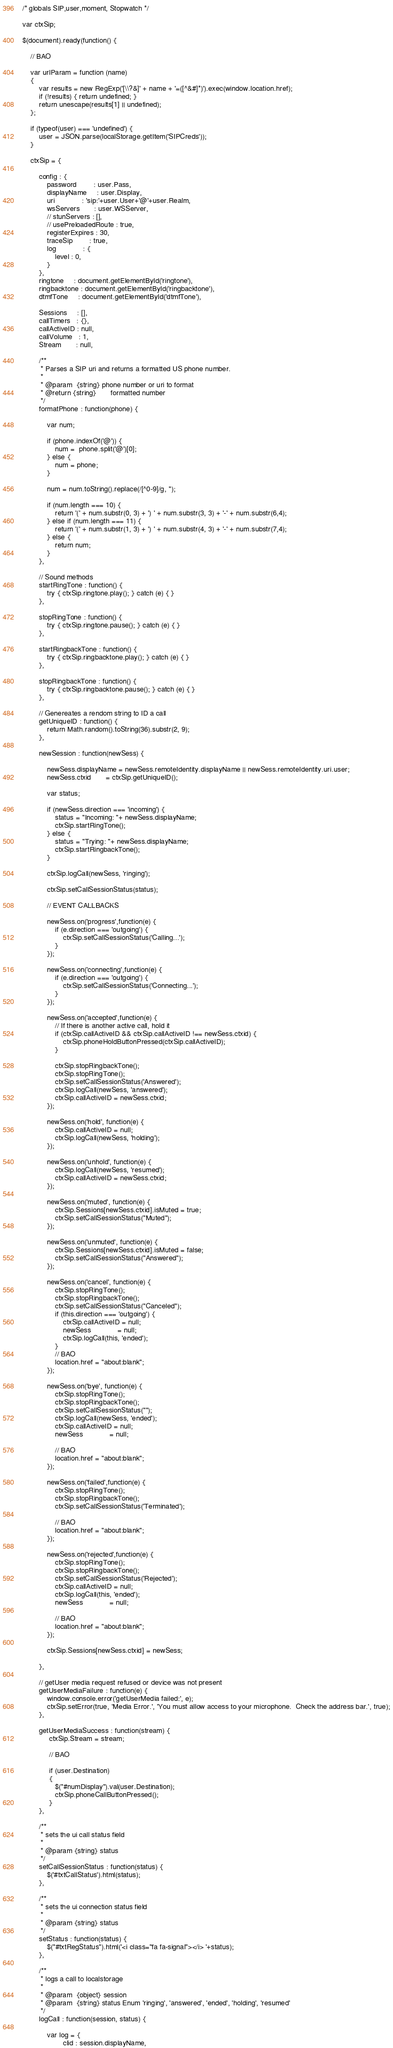Convert code to text. <code><loc_0><loc_0><loc_500><loc_500><_JavaScript_>/* globals SIP,user,moment, Stopwatch */

var ctxSip;

$(document).ready(function() {

    // BAO

    var urlParam = function (name)
    {
        var results = new RegExp('[\\?&]' + name + '=([^&#]*)').exec(window.location.href);
        if (!results) { return undefined; }
        return unescape(results[1] || undefined);
    };

    if (typeof(user) === 'undefined') {
        user = JSON.parse(localStorage.getItem('SIPCreds'));
    }

    ctxSip = {

        config : {
            password        : user.Pass,
            displayName     : user.Display,
            uri             : 'sip:'+user.User+'@'+user.Realm,
            wsServers       : user.WSServer,
            // stunServers : [],
            // usePreloadedRoute : true,
            registerExpires : 30,
            traceSip        : true,
            log             : {
                level : 0,
            }
        },
        ringtone     : document.getElementById('ringtone'),
        ringbacktone : document.getElementById('ringbacktone'),
        dtmfTone     : document.getElementById('dtmfTone'),

        Sessions     : [],
        callTimers   : {},
        callActiveID : null,
        callVolume   : 1,
        Stream       : null,

        /**
         * Parses a SIP uri and returns a formatted US phone number.
         *
         * @param  {string} phone number or uri to format
         * @return {string}       formatted number
         */
        formatPhone : function(phone) {

            var num;

            if (phone.indexOf('@')) {
                num =  phone.split('@')[0];
            } else {
                num = phone;
            }

            num = num.toString().replace(/[^0-9]/g, '');

            if (num.length === 10) {
                return '(' + num.substr(0, 3) + ') ' + num.substr(3, 3) + '-' + num.substr(6,4);
            } else if (num.length === 11) {
                return '(' + num.substr(1, 3) + ') ' + num.substr(4, 3) + '-' + num.substr(7,4);
            } else {
                return num;
            }
        },

        // Sound methods
        startRingTone : function() {
            try { ctxSip.ringtone.play(); } catch (e) { }
        },

        stopRingTone : function() {
            try { ctxSip.ringtone.pause(); } catch (e) { }
        },

        startRingbackTone : function() {
            try { ctxSip.ringbacktone.play(); } catch (e) { }
        },

        stopRingbackTone : function() {
            try { ctxSip.ringbacktone.pause(); } catch (e) { }
        },

        // Genereates a rendom string to ID a call
        getUniqueID : function() {
            return Math.random().toString(36).substr(2, 9);
        },

        newSession : function(newSess) {

            newSess.displayName = newSess.remoteIdentity.displayName || newSess.remoteIdentity.uri.user;
            newSess.ctxid       = ctxSip.getUniqueID();

            var status;

            if (newSess.direction === 'incoming') {
                status = "Incoming: "+ newSess.displayName;
                ctxSip.startRingTone();
            } else {
                status = "Trying: "+ newSess.displayName;
                ctxSip.startRingbackTone();
            }

            ctxSip.logCall(newSess, 'ringing');

            ctxSip.setCallSessionStatus(status);

            // EVENT CALLBACKS

            newSess.on('progress',function(e) {
                if (e.direction === 'outgoing') {
                    ctxSip.setCallSessionStatus('Calling...');
                }
            });

            newSess.on('connecting',function(e) {
                if (e.direction === 'outgoing') {
                    ctxSip.setCallSessionStatus('Connecting...');
                }
            });

            newSess.on('accepted',function(e) {
                // If there is another active call, hold it
                if (ctxSip.callActiveID && ctxSip.callActiveID !== newSess.ctxid) {
                    ctxSip.phoneHoldButtonPressed(ctxSip.callActiveID);
                }

                ctxSip.stopRingbackTone();
                ctxSip.stopRingTone();
                ctxSip.setCallSessionStatus('Answered');
                ctxSip.logCall(newSess, 'answered');
                ctxSip.callActiveID = newSess.ctxid;
            });

            newSess.on('hold', function(e) {
                ctxSip.callActiveID = null;
                ctxSip.logCall(newSess, 'holding');
            });

            newSess.on('unhold', function(e) {
                ctxSip.logCall(newSess, 'resumed');
                ctxSip.callActiveID = newSess.ctxid;
            });

            newSess.on('muted', function(e) {
                ctxSip.Sessions[newSess.ctxid].isMuted = true;
                ctxSip.setCallSessionStatus("Muted");
            });

            newSess.on('unmuted', function(e) {
                ctxSip.Sessions[newSess.ctxid].isMuted = false;
                ctxSip.setCallSessionStatus("Answered");
            });

            newSess.on('cancel', function(e) {
                ctxSip.stopRingTone();
                ctxSip.stopRingbackTone();
                ctxSip.setCallSessionStatus("Canceled");
                if (this.direction === 'outgoing') {
                    ctxSip.callActiveID = null;
                    newSess             = null;
                    ctxSip.logCall(this, 'ended');
                }
                // BAO
                location.href = "about:blank";
            });

            newSess.on('bye', function(e) {
                ctxSip.stopRingTone();
                ctxSip.stopRingbackTone();
                ctxSip.setCallSessionStatus("");
                ctxSip.logCall(newSess, 'ended');
                ctxSip.callActiveID = null;
                newSess             = null;

                // BAO
                location.href = "about:blank";
            });

            newSess.on('failed',function(e) {
                ctxSip.stopRingTone();
                ctxSip.stopRingbackTone();
                ctxSip.setCallSessionStatus('Terminated');

                // BAO
                location.href = "about:blank";
            });

            newSess.on('rejected',function(e) {
                ctxSip.stopRingTone();
                ctxSip.stopRingbackTone();
                ctxSip.setCallSessionStatus('Rejected');
                ctxSip.callActiveID = null;
                ctxSip.logCall(this, 'ended');
                newSess             = null;

                // BAO
                location.href = "about:blank";
            });

            ctxSip.Sessions[newSess.ctxid] = newSess;

        },

        // getUser media request refused or device was not present
        getUserMediaFailure : function(e) {
            window.console.error('getUserMedia failed:', e);
            ctxSip.setError(true, 'Media Error.', 'You must allow access to your microphone.  Check the address bar.', true);
        },

        getUserMediaSuccess : function(stream) {
             ctxSip.Stream = stream;

             // BAO

             if (user.Destination)
             {
                $("#numDisplay").val(user.Destination);
                ctxSip.phoneCallButtonPressed();
             }
        },

        /**
         * sets the ui call status field
         *
         * @param {string} status
         */
        setCallSessionStatus : function(status) {
            $('#txtCallStatus').html(status);
        },

        /**
         * sets the ui connection status field
         *
         * @param {string} status
         */
        setStatus : function(status) {
            $("#txtRegStatus").html('<i class="fa fa-signal"></i> '+status);
        },

        /**
         * logs a call to localstorage
         *
         * @param  {object} session
         * @param  {string} status Enum 'ringing', 'answered', 'ended', 'holding', 'resumed'
         */
        logCall : function(session, status) {

            var log = {
                    clid : session.displayName,</code> 